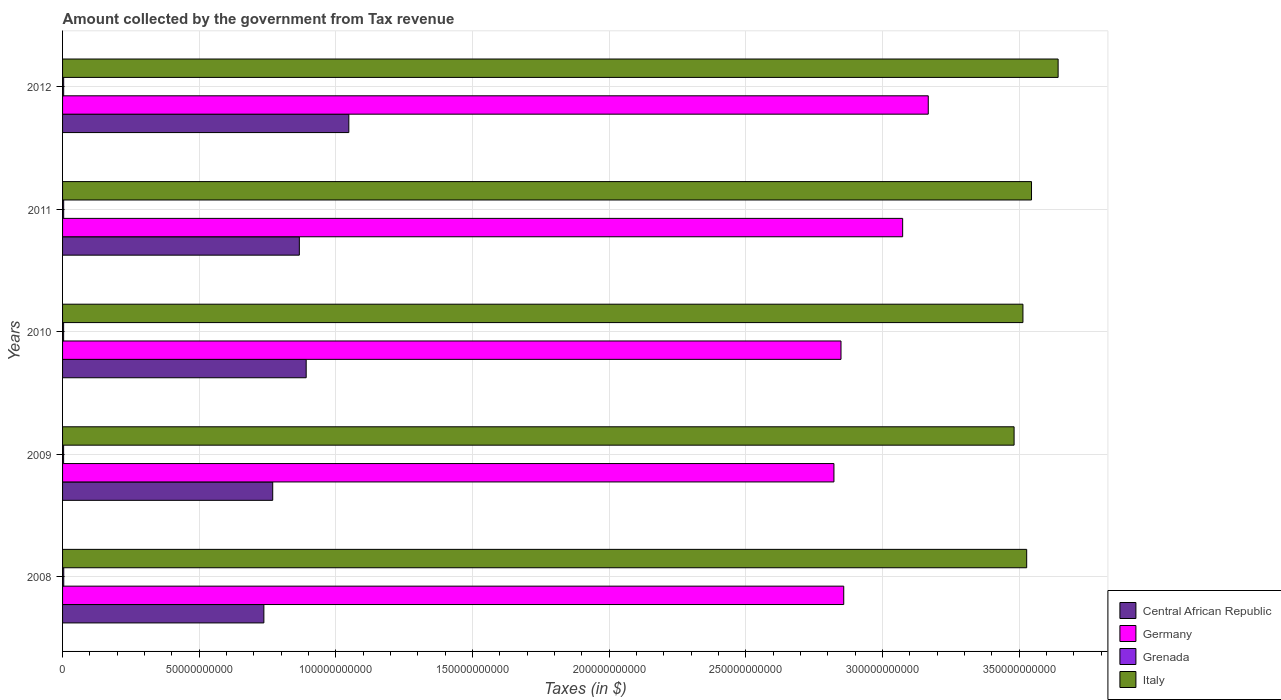How many different coloured bars are there?
Provide a succinct answer. 4. Are the number of bars per tick equal to the number of legend labels?
Provide a succinct answer. Yes. Are the number of bars on each tick of the Y-axis equal?
Ensure brevity in your answer.  Yes. How many bars are there on the 5th tick from the bottom?
Give a very brief answer. 4. What is the amount collected by the government from tax revenue in Grenada in 2009?
Keep it short and to the point. 3.80e+08. Across all years, what is the maximum amount collected by the government from tax revenue in Central African Republic?
Give a very brief answer. 1.05e+11. Across all years, what is the minimum amount collected by the government from tax revenue in Germany?
Offer a terse response. 2.82e+11. In which year was the amount collected by the government from tax revenue in Central African Republic minimum?
Make the answer very short. 2008. What is the total amount collected by the government from tax revenue in Italy in the graph?
Keep it short and to the point. 1.77e+12. What is the difference between the amount collected by the government from tax revenue in Germany in 2011 and that in 2012?
Keep it short and to the point. -9.37e+09. What is the difference between the amount collected by the government from tax revenue in Italy in 2010 and the amount collected by the government from tax revenue in Germany in 2012?
Your response must be concise. 3.46e+1. What is the average amount collected by the government from tax revenue in Germany per year?
Your answer should be very brief. 2.95e+11. In the year 2008, what is the difference between the amount collected by the government from tax revenue in Grenada and amount collected by the government from tax revenue in Italy?
Keep it short and to the point. -3.52e+11. What is the ratio of the amount collected by the government from tax revenue in Italy in 2009 to that in 2012?
Keep it short and to the point. 0.96. Is the difference between the amount collected by the government from tax revenue in Grenada in 2011 and 2012 greater than the difference between the amount collected by the government from tax revenue in Italy in 2011 and 2012?
Your answer should be very brief. Yes. What is the difference between the highest and the second highest amount collected by the government from tax revenue in Grenada?
Give a very brief answer. 3.06e+07. What is the difference between the highest and the lowest amount collected by the government from tax revenue in Germany?
Your answer should be very brief. 3.45e+1. Is the sum of the amount collected by the government from tax revenue in Italy in 2009 and 2010 greater than the maximum amount collected by the government from tax revenue in Grenada across all years?
Provide a short and direct response. Yes. What does the 1st bar from the top in 2008 represents?
Offer a very short reply. Italy. What does the 3rd bar from the bottom in 2010 represents?
Offer a very short reply. Grenada. How many bars are there?
Keep it short and to the point. 20. Are all the bars in the graph horizontal?
Make the answer very short. Yes. Does the graph contain any zero values?
Keep it short and to the point. No. Where does the legend appear in the graph?
Offer a very short reply. Bottom right. How many legend labels are there?
Offer a very short reply. 4. What is the title of the graph?
Offer a very short reply. Amount collected by the government from Tax revenue. Does "Barbados" appear as one of the legend labels in the graph?
Offer a terse response. No. What is the label or title of the X-axis?
Provide a succinct answer. Taxes (in $). What is the Taxes (in $) in Central African Republic in 2008?
Give a very brief answer. 7.37e+1. What is the Taxes (in $) of Germany in 2008?
Your answer should be compact. 2.86e+11. What is the Taxes (in $) in Grenada in 2008?
Your answer should be very brief. 4.34e+08. What is the Taxes (in $) of Italy in 2008?
Offer a terse response. 3.53e+11. What is the Taxes (in $) in Central African Republic in 2009?
Your answer should be very brief. 7.69e+1. What is the Taxes (in $) in Germany in 2009?
Ensure brevity in your answer.  2.82e+11. What is the Taxes (in $) in Grenada in 2009?
Your response must be concise. 3.80e+08. What is the Taxes (in $) of Italy in 2009?
Your answer should be very brief. 3.48e+11. What is the Taxes (in $) in Central African Republic in 2010?
Make the answer very short. 8.91e+1. What is the Taxes (in $) of Germany in 2010?
Keep it short and to the point. 2.85e+11. What is the Taxes (in $) of Grenada in 2010?
Offer a very short reply. 3.90e+08. What is the Taxes (in $) in Italy in 2010?
Your answer should be compact. 3.51e+11. What is the Taxes (in $) of Central African Republic in 2011?
Make the answer very short. 8.66e+1. What is the Taxes (in $) in Germany in 2011?
Ensure brevity in your answer.  3.07e+11. What is the Taxes (in $) of Grenada in 2011?
Make the answer very short. 4.03e+08. What is the Taxes (in $) in Italy in 2011?
Offer a very short reply. 3.55e+11. What is the Taxes (in $) of Central African Republic in 2012?
Ensure brevity in your answer.  1.05e+11. What is the Taxes (in $) of Germany in 2012?
Ensure brevity in your answer.  3.17e+11. What is the Taxes (in $) in Grenada in 2012?
Offer a terse response. 4.03e+08. What is the Taxes (in $) in Italy in 2012?
Ensure brevity in your answer.  3.64e+11. Across all years, what is the maximum Taxes (in $) of Central African Republic?
Keep it short and to the point. 1.05e+11. Across all years, what is the maximum Taxes (in $) in Germany?
Your answer should be very brief. 3.17e+11. Across all years, what is the maximum Taxes (in $) of Grenada?
Your response must be concise. 4.34e+08. Across all years, what is the maximum Taxes (in $) of Italy?
Offer a very short reply. 3.64e+11. Across all years, what is the minimum Taxes (in $) in Central African Republic?
Make the answer very short. 7.37e+1. Across all years, what is the minimum Taxes (in $) of Germany?
Provide a succinct answer. 2.82e+11. Across all years, what is the minimum Taxes (in $) in Grenada?
Your answer should be very brief. 3.80e+08. Across all years, what is the minimum Taxes (in $) in Italy?
Provide a short and direct response. 3.48e+11. What is the total Taxes (in $) of Central African Republic in the graph?
Your response must be concise. 4.31e+11. What is the total Taxes (in $) in Germany in the graph?
Offer a terse response. 1.48e+12. What is the total Taxes (in $) of Grenada in the graph?
Provide a short and direct response. 2.01e+09. What is the total Taxes (in $) in Italy in the graph?
Ensure brevity in your answer.  1.77e+12. What is the difference between the Taxes (in $) in Central African Republic in 2008 and that in 2009?
Make the answer very short. -3.24e+09. What is the difference between the Taxes (in $) of Germany in 2008 and that in 2009?
Provide a short and direct response. 3.58e+09. What is the difference between the Taxes (in $) of Grenada in 2008 and that in 2009?
Give a very brief answer. 5.39e+07. What is the difference between the Taxes (in $) of Italy in 2008 and that in 2009?
Give a very brief answer. 4.60e+09. What is the difference between the Taxes (in $) of Central African Republic in 2008 and that in 2010?
Keep it short and to the point. -1.55e+1. What is the difference between the Taxes (in $) of Grenada in 2008 and that in 2010?
Your response must be concise. 4.39e+07. What is the difference between the Taxes (in $) in Italy in 2008 and that in 2010?
Provide a succinct answer. 1.37e+09. What is the difference between the Taxes (in $) of Central African Republic in 2008 and that in 2011?
Offer a terse response. -1.30e+1. What is the difference between the Taxes (in $) of Germany in 2008 and that in 2011?
Give a very brief answer. -2.16e+1. What is the difference between the Taxes (in $) of Grenada in 2008 and that in 2011?
Keep it short and to the point. 3.08e+07. What is the difference between the Taxes (in $) of Italy in 2008 and that in 2011?
Provide a succinct answer. -1.77e+09. What is the difference between the Taxes (in $) in Central African Republic in 2008 and that in 2012?
Provide a succinct answer. -3.11e+1. What is the difference between the Taxes (in $) of Germany in 2008 and that in 2012?
Offer a very short reply. -3.09e+1. What is the difference between the Taxes (in $) of Grenada in 2008 and that in 2012?
Ensure brevity in your answer.  3.06e+07. What is the difference between the Taxes (in $) in Italy in 2008 and that in 2012?
Provide a succinct answer. -1.15e+1. What is the difference between the Taxes (in $) of Central African Republic in 2009 and that in 2010?
Ensure brevity in your answer.  -1.22e+1. What is the difference between the Taxes (in $) in Germany in 2009 and that in 2010?
Make the answer very short. -2.58e+09. What is the difference between the Taxes (in $) in Grenada in 2009 and that in 2010?
Your response must be concise. -1.00e+07. What is the difference between the Taxes (in $) in Italy in 2009 and that in 2010?
Your response must be concise. -3.24e+09. What is the difference between the Taxes (in $) of Central African Republic in 2009 and that in 2011?
Give a very brief answer. -9.74e+09. What is the difference between the Taxes (in $) in Germany in 2009 and that in 2011?
Your answer should be very brief. -2.51e+1. What is the difference between the Taxes (in $) in Grenada in 2009 and that in 2011?
Provide a succinct answer. -2.31e+07. What is the difference between the Taxes (in $) in Italy in 2009 and that in 2011?
Offer a very short reply. -6.37e+09. What is the difference between the Taxes (in $) of Central African Republic in 2009 and that in 2012?
Your answer should be very brief. -2.78e+1. What is the difference between the Taxes (in $) in Germany in 2009 and that in 2012?
Ensure brevity in your answer.  -3.45e+1. What is the difference between the Taxes (in $) of Grenada in 2009 and that in 2012?
Offer a terse response. -2.33e+07. What is the difference between the Taxes (in $) of Italy in 2009 and that in 2012?
Keep it short and to the point. -1.61e+1. What is the difference between the Taxes (in $) of Central African Republic in 2010 and that in 2011?
Keep it short and to the point. 2.50e+09. What is the difference between the Taxes (in $) of Germany in 2010 and that in 2011?
Make the answer very short. -2.26e+1. What is the difference between the Taxes (in $) of Grenada in 2010 and that in 2011?
Your response must be concise. -1.31e+07. What is the difference between the Taxes (in $) in Italy in 2010 and that in 2011?
Provide a short and direct response. -3.14e+09. What is the difference between the Taxes (in $) in Central African Republic in 2010 and that in 2012?
Offer a very short reply. -1.56e+1. What is the difference between the Taxes (in $) in Germany in 2010 and that in 2012?
Offer a terse response. -3.19e+1. What is the difference between the Taxes (in $) in Grenada in 2010 and that in 2012?
Offer a very short reply. -1.33e+07. What is the difference between the Taxes (in $) of Italy in 2010 and that in 2012?
Your response must be concise. -1.29e+1. What is the difference between the Taxes (in $) of Central African Republic in 2011 and that in 2012?
Your answer should be very brief. -1.81e+1. What is the difference between the Taxes (in $) in Germany in 2011 and that in 2012?
Offer a very short reply. -9.37e+09. What is the difference between the Taxes (in $) in Grenada in 2011 and that in 2012?
Your answer should be very brief. -2.00e+05. What is the difference between the Taxes (in $) in Italy in 2011 and that in 2012?
Provide a succinct answer. -9.73e+09. What is the difference between the Taxes (in $) of Central African Republic in 2008 and the Taxes (in $) of Germany in 2009?
Keep it short and to the point. -2.09e+11. What is the difference between the Taxes (in $) of Central African Republic in 2008 and the Taxes (in $) of Grenada in 2009?
Your answer should be compact. 7.33e+1. What is the difference between the Taxes (in $) in Central African Republic in 2008 and the Taxes (in $) in Italy in 2009?
Give a very brief answer. -2.74e+11. What is the difference between the Taxes (in $) in Germany in 2008 and the Taxes (in $) in Grenada in 2009?
Make the answer very short. 2.85e+11. What is the difference between the Taxes (in $) of Germany in 2008 and the Taxes (in $) of Italy in 2009?
Provide a succinct answer. -6.23e+1. What is the difference between the Taxes (in $) of Grenada in 2008 and the Taxes (in $) of Italy in 2009?
Your answer should be very brief. -3.48e+11. What is the difference between the Taxes (in $) of Central African Republic in 2008 and the Taxes (in $) of Germany in 2010?
Your response must be concise. -2.11e+11. What is the difference between the Taxes (in $) of Central African Republic in 2008 and the Taxes (in $) of Grenada in 2010?
Offer a very short reply. 7.33e+1. What is the difference between the Taxes (in $) in Central African Republic in 2008 and the Taxes (in $) in Italy in 2010?
Provide a succinct answer. -2.78e+11. What is the difference between the Taxes (in $) in Germany in 2008 and the Taxes (in $) in Grenada in 2010?
Provide a succinct answer. 2.85e+11. What is the difference between the Taxes (in $) of Germany in 2008 and the Taxes (in $) of Italy in 2010?
Your answer should be very brief. -6.56e+1. What is the difference between the Taxes (in $) in Grenada in 2008 and the Taxes (in $) in Italy in 2010?
Provide a succinct answer. -3.51e+11. What is the difference between the Taxes (in $) of Central African Republic in 2008 and the Taxes (in $) of Germany in 2011?
Provide a short and direct response. -2.34e+11. What is the difference between the Taxes (in $) in Central African Republic in 2008 and the Taxes (in $) in Grenada in 2011?
Make the answer very short. 7.32e+1. What is the difference between the Taxes (in $) of Central African Republic in 2008 and the Taxes (in $) of Italy in 2011?
Offer a terse response. -2.81e+11. What is the difference between the Taxes (in $) of Germany in 2008 and the Taxes (in $) of Grenada in 2011?
Offer a terse response. 2.85e+11. What is the difference between the Taxes (in $) of Germany in 2008 and the Taxes (in $) of Italy in 2011?
Offer a very short reply. -6.87e+1. What is the difference between the Taxes (in $) of Grenada in 2008 and the Taxes (in $) of Italy in 2011?
Your response must be concise. -3.54e+11. What is the difference between the Taxes (in $) in Central African Republic in 2008 and the Taxes (in $) in Germany in 2012?
Make the answer very short. -2.43e+11. What is the difference between the Taxes (in $) in Central African Republic in 2008 and the Taxes (in $) in Grenada in 2012?
Offer a terse response. 7.32e+1. What is the difference between the Taxes (in $) in Central African Republic in 2008 and the Taxes (in $) in Italy in 2012?
Provide a short and direct response. -2.91e+11. What is the difference between the Taxes (in $) of Germany in 2008 and the Taxes (in $) of Grenada in 2012?
Your answer should be compact. 2.85e+11. What is the difference between the Taxes (in $) of Germany in 2008 and the Taxes (in $) of Italy in 2012?
Make the answer very short. -7.84e+1. What is the difference between the Taxes (in $) of Grenada in 2008 and the Taxes (in $) of Italy in 2012?
Make the answer very short. -3.64e+11. What is the difference between the Taxes (in $) of Central African Republic in 2009 and the Taxes (in $) of Germany in 2010?
Provide a succinct answer. -2.08e+11. What is the difference between the Taxes (in $) in Central African Republic in 2009 and the Taxes (in $) in Grenada in 2010?
Offer a very short reply. 7.65e+1. What is the difference between the Taxes (in $) in Central African Republic in 2009 and the Taxes (in $) in Italy in 2010?
Your answer should be very brief. -2.74e+11. What is the difference between the Taxes (in $) of Germany in 2009 and the Taxes (in $) of Grenada in 2010?
Offer a terse response. 2.82e+11. What is the difference between the Taxes (in $) of Germany in 2009 and the Taxes (in $) of Italy in 2010?
Make the answer very short. -6.92e+1. What is the difference between the Taxes (in $) of Grenada in 2009 and the Taxes (in $) of Italy in 2010?
Your answer should be very brief. -3.51e+11. What is the difference between the Taxes (in $) of Central African Republic in 2009 and the Taxes (in $) of Germany in 2011?
Make the answer very short. -2.30e+11. What is the difference between the Taxes (in $) in Central African Republic in 2009 and the Taxes (in $) in Grenada in 2011?
Offer a terse response. 7.65e+1. What is the difference between the Taxes (in $) in Central African Republic in 2009 and the Taxes (in $) in Italy in 2011?
Your answer should be compact. -2.78e+11. What is the difference between the Taxes (in $) of Germany in 2009 and the Taxes (in $) of Grenada in 2011?
Make the answer very short. 2.82e+11. What is the difference between the Taxes (in $) in Germany in 2009 and the Taxes (in $) in Italy in 2011?
Your response must be concise. -7.23e+1. What is the difference between the Taxes (in $) in Grenada in 2009 and the Taxes (in $) in Italy in 2011?
Your response must be concise. -3.54e+11. What is the difference between the Taxes (in $) of Central African Republic in 2009 and the Taxes (in $) of Germany in 2012?
Offer a very short reply. -2.40e+11. What is the difference between the Taxes (in $) in Central African Republic in 2009 and the Taxes (in $) in Grenada in 2012?
Your response must be concise. 7.65e+1. What is the difference between the Taxes (in $) of Central African Republic in 2009 and the Taxes (in $) of Italy in 2012?
Make the answer very short. -2.87e+11. What is the difference between the Taxes (in $) in Germany in 2009 and the Taxes (in $) in Grenada in 2012?
Provide a short and direct response. 2.82e+11. What is the difference between the Taxes (in $) in Germany in 2009 and the Taxes (in $) in Italy in 2012?
Give a very brief answer. -8.20e+1. What is the difference between the Taxes (in $) in Grenada in 2009 and the Taxes (in $) in Italy in 2012?
Provide a succinct answer. -3.64e+11. What is the difference between the Taxes (in $) in Central African Republic in 2010 and the Taxes (in $) in Germany in 2011?
Offer a terse response. -2.18e+11. What is the difference between the Taxes (in $) of Central African Republic in 2010 and the Taxes (in $) of Grenada in 2011?
Keep it short and to the point. 8.87e+1. What is the difference between the Taxes (in $) in Central African Republic in 2010 and the Taxes (in $) in Italy in 2011?
Provide a succinct answer. -2.65e+11. What is the difference between the Taxes (in $) of Germany in 2010 and the Taxes (in $) of Grenada in 2011?
Provide a short and direct response. 2.84e+11. What is the difference between the Taxes (in $) in Germany in 2010 and the Taxes (in $) in Italy in 2011?
Ensure brevity in your answer.  -6.97e+1. What is the difference between the Taxes (in $) in Grenada in 2010 and the Taxes (in $) in Italy in 2011?
Your response must be concise. -3.54e+11. What is the difference between the Taxes (in $) of Central African Republic in 2010 and the Taxes (in $) of Germany in 2012?
Your answer should be very brief. -2.28e+11. What is the difference between the Taxes (in $) of Central African Republic in 2010 and the Taxes (in $) of Grenada in 2012?
Ensure brevity in your answer.  8.87e+1. What is the difference between the Taxes (in $) of Central African Republic in 2010 and the Taxes (in $) of Italy in 2012?
Offer a terse response. -2.75e+11. What is the difference between the Taxes (in $) in Germany in 2010 and the Taxes (in $) in Grenada in 2012?
Provide a succinct answer. 2.84e+11. What is the difference between the Taxes (in $) in Germany in 2010 and the Taxes (in $) in Italy in 2012?
Keep it short and to the point. -7.94e+1. What is the difference between the Taxes (in $) in Grenada in 2010 and the Taxes (in $) in Italy in 2012?
Provide a succinct answer. -3.64e+11. What is the difference between the Taxes (in $) of Central African Republic in 2011 and the Taxes (in $) of Germany in 2012?
Give a very brief answer. -2.30e+11. What is the difference between the Taxes (in $) in Central African Republic in 2011 and the Taxes (in $) in Grenada in 2012?
Keep it short and to the point. 8.62e+1. What is the difference between the Taxes (in $) of Central African Republic in 2011 and the Taxes (in $) of Italy in 2012?
Ensure brevity in your answer.  -2.78e+11. What is the difference between the Taxes (in $) of Germany in 2011 and the Taxes (in $) of Grenada in 2012?
Give a very brief answer. 3.07e+11. What is the difference between the Taxes (in $) in Germany in 2011 and the Taxes (in $) in Italy in 2012?
Ensure brevity in your answer.  -5.69e+1. What is the difference between the Taxes (in $) of Grenada in 2011 and the Taxes (in $) of Italy in 2012?
Your answer should be compact. -3.64e+11. What is the average Taxes (in $) of Central African Republic per year?
Make the answer very short. 8.62e+1. What is the average Taxes (in $) in Germany per year?
Keep it short and to the point. 2.95e+11. What is the average Taxes (in $) in Grenada per year?
Your answer should be compact. 4.02e+08. What is the average Taxes (in $) of Italy per year?
Offer a terse response. 3.54e+11. In the year 2008, what is the difference between the Taxes (in $) in Central African Republic and Taxes (in $) in Germany?
Make the answer very short. -2.12e+11. In the year 2008, what is the difference between the Taxes (in $) in Central African Republic and Taxes (in $) in Grenada?
Provide a short and direct response. 7.32e+1. In the year 2008, what is the difference between the Taxes (in $) in Central African Republic and Taxes (in $) in Italy?
Provide a succinct answer. -2.79e+11. In the year 2008, what is the difference between the Taxes (in $) in Germany and Taxes (in $) in Grenada?
Offer a terse response. 2.85e+11. In the year 2008, what is the difference between the Taxes (in $) of Germany and Taxes (in $) of Italy?
Offer a terse response. -6.69e+1. In the year 2008, what is the difference between the Taxes (in $) in Grenada and Taxes (in $) in Italy?
Your response must be concise. -3.52e+11. In the year 2009, what is the difference between the Taxes (in $) in Central African Republic and Taxes (in $) in Germany?
Your answer should be compact. -2.05e+11. In the year 2009, what is the difference between the Taxes (in $) in Central African Republic and Taxes (in $) in Grenada?
Your answer should be very brief. 7.65e+1. In the year 2009, what is the difference between the Taxes (in $) of Central African Republic and Taxes (in $) of Italy?
Ensure brevity in your answer.  -2.71e+11. In the year 2009, what is the difference between the Taxes (in $) in Germany and Taxes (in $) in Grenada?
Give a very brief answer. 2.82e+11. In the year 2009, what is the difference between the Taxes (in $) of Germany and Taxes (in $) of Italy?
Your answer should be compact. -6.59e+1. In the year 2009, what is the difference between the Taxes (in $) in Grenada and Taxes (in $) in Italy?
Your answer should be very brief. -3.48e+11. In the year 2010, what is the difference between the Taxes (in $) of Central African Republic and Taxes (in $) of Germany?
Offer a very short reply. -1.96e+11. In the year 2010, what is the difference between the Taxes (in $) in Central African Republic and Taxes (in $) in Grenada?
Provide a succinct answer. 8.87e+1. In the year 2010, what is the difference between the Taxes (in $) of Central African Republic and Taxes (in $) of Italy?
Provide a short and direct response. -2.62e+11. In the year 2010, what is the difference between the Taxes (in $) in Germany and Taxes (in $) in Grenada?
Offer a very short reply. 2.84e+11. In the year 2010, what is the difference between the Taxes (in $) of Germany and Taxes (in $) of Italy?
Make the answer very short. -6.66e+1. In the year 2010, what is the difference between the Taxes (in $) of Grenada and Taxes (in $) of Italy?
Your answer should be compact. -3.51e+11. In the year 2011, what is the difference between the Taxes (in $) of Central African Republic and Taxes (in $) of Germany?
Offer a terse response. -2.21e+11. In the year 2011, what is the difference between the Taxes (in $) in Central African Republic and Taxes (in $) in Grenada?
Provide a short and direct response. 8.62e+1. In the year 2011, what is the difference between the Taxes (in $) in Central African Republic and Taxes (in $) in Italy?
Provide a succinct answer. -2.68e+11. In the year 2011, what is the difference between the Taxes (in $) of Germany and Taxes (in $) of Grenada?
Offer a very short reply. 3.07e+11. In the year 2011, what is the difference between the Taxes (in $) in Germany and Taxes (in $) in Italy?
Ensure brevity in your answer.  -4.71e+1. In the year 2011, what is the difference between the Taxes (in $) in Grenada and Taxes (in $) in Italy?
Ensure brevity in your answer.  -3.54e+11. In the year 2012, what is the difference between the Taxes (in $) in Central African Republic and Taxes (in $) in Germany?
Offer a very short reply. -2.12e+11. In the year 2012, what is the difference between the Taxes (in $) in Central African Republic and Taxes (in $) in Grenada?
Keep it short and to the point. 1.04e+11. In the year 2012, what is the difference between the Taxes (in $) in Central African Republic and Taxes (in $) in Italy?
Your response must be concise. -2.60e+11. In the year 2012, what is the difference between the Taxes (in $) in Germany and Taxes (in $) in Grenada?
Your response must be concise. 3.16e+11. In the year 2012, what is the difference between the Taxes (in $) of Germany and Taxes (in $) of Italy?
Your response must be concise. -4.75e+1. In the year 2012, what is the difference between the Taxes (in $) of Grenada and Taxes (in $) of Italy?
Provide a succinct answer. -3.64e+11. What is the ratio of the Taxes (in $) in Central African Republic in 2008 to that in 2009?
Provide a short and direct response. 0.96. What is the ratio of the Taxes (in $) of Germany in 2008 to that in 2009?
Your response must be concise. 1.01. What is the ratio of the Taxes (in $) in Grenada in 2008 to that in 2009?
Give a very brief answer. 1.14. What is the ratio of the Taxes (in $) in Italy in 2008 to that in 2009?
Give a very brief answer. 1.01. What is the ratio of the Taxes (in $) of Central African Republic in 2008 to that in 2010?
Your response must be concise. 0.83. What is the ratio of the Taxes (in $) of Germany in 2008 to that in 2010?
Your answer should be compact. 1. What is the ratio of the Taxes (in $) in Grenada in 2008 to that in 2010?
Provide a short and direct response. 1.11. What is the ratio of the Taxes (in $) in Italy in 2008 to that in 2010?
Provide a short and direct response. 1. What is the ratio of the Taxes (in $) in Central African Republic in 2008 to that in 2011?
Offer a terse response. 0.85. What is the ratio of the Taxes (in $) of Germany in 2008 to that in 2011?
Make the answer very short. 0.93. What is the ratio of the Taxes (in $) of Grenada in 2008 to that in 2011?
Your answer should be very brief. 1.08. What is the ratio of the Taxes (in $) in Italy in 2008 to that in 2011?
Offer a very short reply. 0.99. What is the ratio of the Taxes (in $) in Central African Republic in 2008 to that in 2012?
Provide a succinct answer. 0.7. What is the ratio of the Taxes (in $) of Germany in 2008 to that in 2012?
Make the answer very short. 0.9. What is the ratio of the Taxes (in $) in Grenada in 2008 to that in 2012?
Your response must be concise. 1.08. What is the ratio of the Taxes (in $) in Italy in 2008 to that in 2012?
Your answer should be compact. 0.97. What is the ratio of the Taxes (in $) of Central African Republic in 2009 to that in 2010?
Provide a succinct answer. 0.86. What is the ratio of the Taxes (in $) in Germany in 2009 to that in 2010?
Make the answer very short. 0.99. What is the ratio of the Taxes (in $) in Grenada in 2009 to that in 2010?
Keep it short and to the point. 0.97. What is the ratio of the Taxes (in $) in Central African Republic in 2009 to that in 2011?
Provide a succinct answer. 0.89. What is the ratio of the Taxes (in $) of Germany in 2009 to that in 2011?
Provide a short and direct response. 0.92. What is the ratio of the Taxes (in $) of Grenada in 2009 to that in 2011?
Keep it short and to the point. 0.94. What is the ratio of the Taxes (in $) in Italy in 2009 to that in 2011?
Provide a succinct answer. 0.98. What is the ratio of the Taxes (in $) in Central African Republic in 2009 to that in 2012?
Provide a succinct answer. 0.73. What is the ratio of the Taxes (in $) of Germany in 2009 to that in 2012?
Give a very brief answer. 0.89. What is the ratio of the Taxes (in $) in Grenada in 2009 to that in 2012?
Your answer should be compact. 0.94. What is the ratio of the Taxes (in $) of Italy in 2009 to that in 2012?
Provide a succinct answer. 0.96. What is the ratio of the Taxes (in $) of Central African Republic in 2010 to that in 2011?
Give a very brief answer. 1.03. What is the ratio of the Taxes (in $) of Germany in 2010 to that in 2011?
Give a very brief answer. 0.93. What is the ratio of the Taxes (in $) in Grenada in 2010 to that in 2011?
Give a very brief answer. 0.97. What is the ratio of the Taxes (in $) in Central African Republic in 2010 to that in 2012?
Provide a succinct answer. 0.85. What is the ratio of the Taxes (in $) in Germany in 2010 to that in 2012?
Provide a short and direct response. 0.9. What is the ratio of the Taxes (in $) in Grenada in 2010 to that in 2012?
Your answer should be very brief. 0.97. What is the ratio of the Taxes (in $) of Italy in 2010 to that in 2012?
Your response must be concise. 0.96. What is the ratio of the Taxes (in $) of Central African Republic in 2011 to that in 2012?
Keep it short and to the point. 0.83. What is the ratio of the Taxes (in $) in Germany in 2011 to that in 2012?
Keep it short and to the point. 0.97. What is the ratio of the Taxes (in $) of Italy in 2011 to that in 2012?
Offer a very short reply. 0.97. What is the difference between the highest and the second highest Taxes (in $) in Central African Republic?
Provide a short and direct response. 1.56e+1. What is the difference between the highest and the second highest Taxes (in $) of Germany?
Ensure brevity in your answer.  9.37e+09. What is the difference between the highest and the second highest Taxes (in $) in Grenada?
Ensure brevity in your answer.  3.06e+07. What is the difference between the highest and the second highest Taxes (in $) of Italy?
Provide a succinct answer. 9.73e+09. What is the difference between the highest and the lowest Taxes (in $) of Central African Republic?
Your response must be concise. 3.11e+1. What is the difference between the highest and the lowest Taxes (in $) in Germany?
Offer a very short reply. 3.45e+1. What is the difference between the highest and the lowest Taxes (in $) in Grenada?
Offer a terse response. 5.39e+07. What is the difference between the highest and the lowest Taxes (in $) of Italy?
Your answer should be compact. 1.61e+1. 